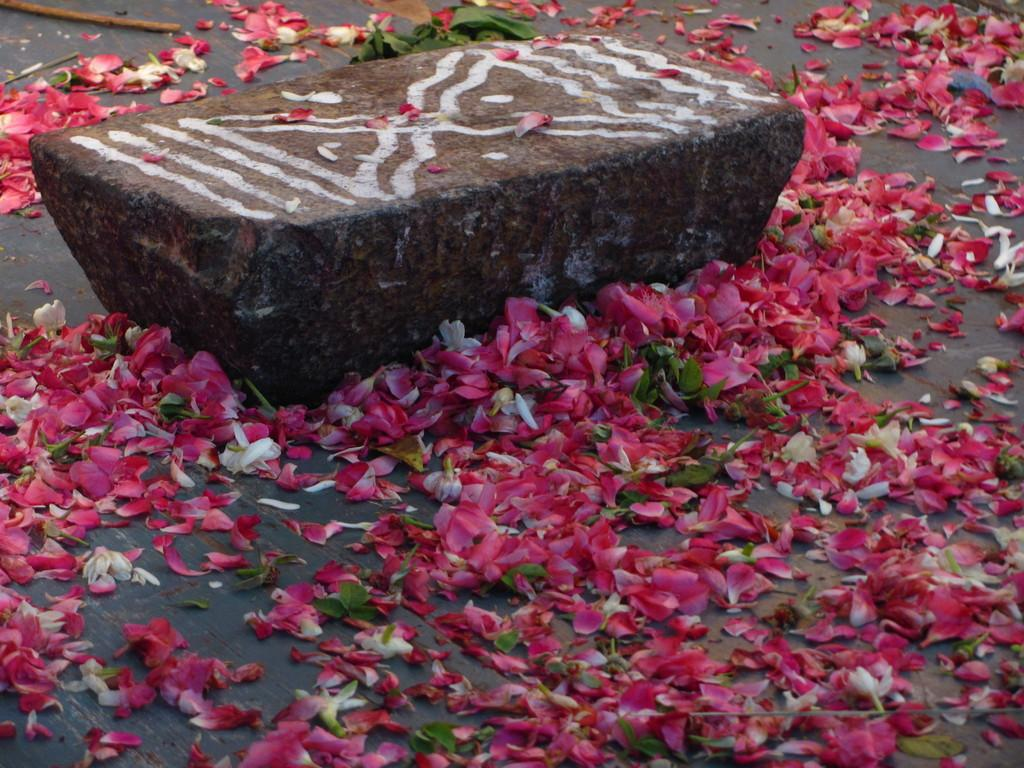What is depicted on the stone in the image? There are paintings on the stone in the image. What can be seen on the floor in the image? There are flower petals and leaves on the floor in the image. How many books are stacked on the stone in the image? There are no books present in the image; it features a stone with paintings and flower petals and leaves on the floor. 